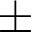<formula> <loc_0><loc_0><loc_500><loc_500>\pm</formula> 